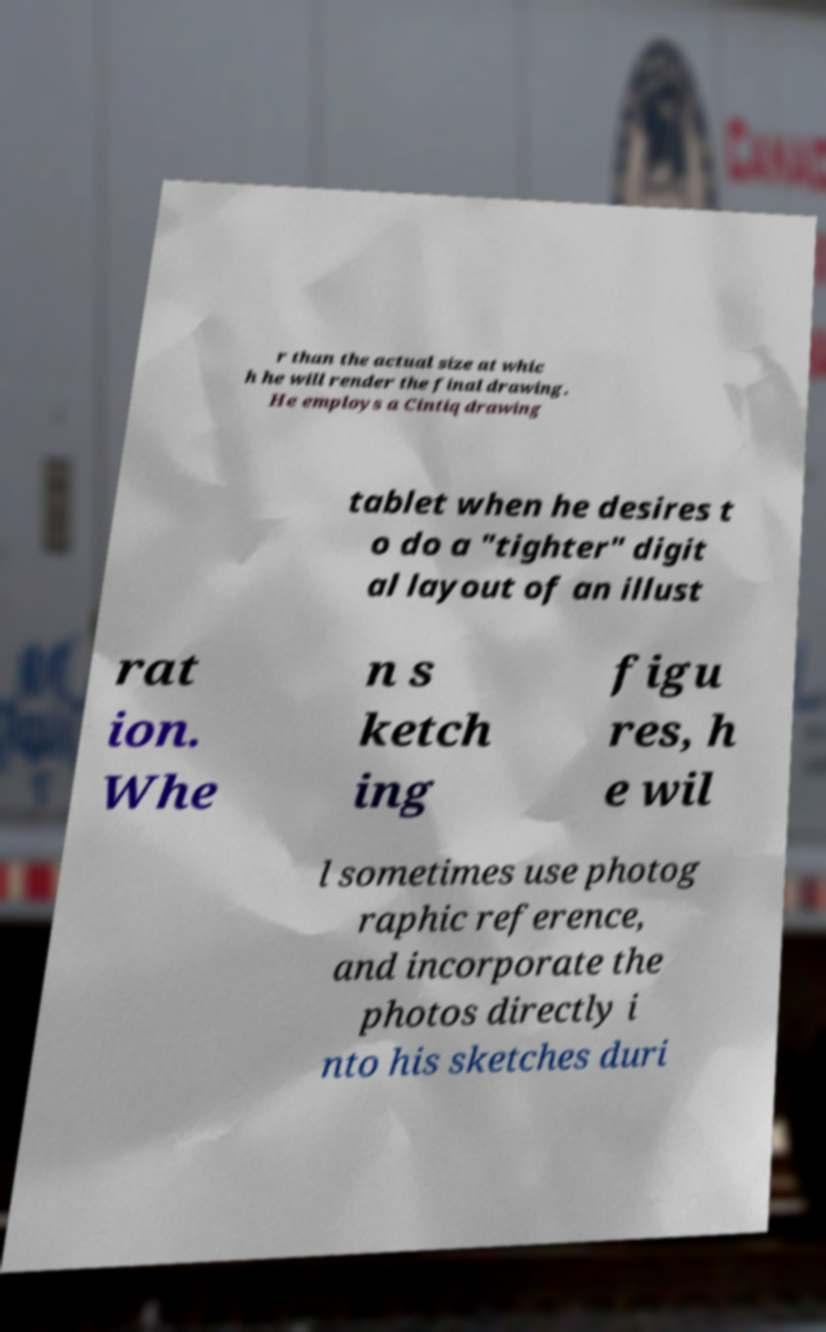Can you read and provide the text displayed in the image?This photo seems to have some interesting text. Can you extract and type it out for me? r than the actual size at whic h he will render the final drawing. He employs a Cintiq drawing tablet when he desires t o do a "tighter" digit al layout of an illust rat ion. Whe n s ketch ing figu res, h e wil l sometimes use photog raphic reference, and incorporate the photos directly i nto his sketches duri 